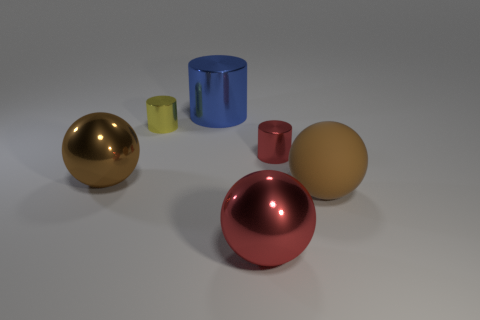Are there any other things that have the same material as the large cylinder?
Your answer should be very brief. Yes. What size is the red cylinder?
Provide a succinct answer. Small. What material is the large sphere left of the tiny cylinder that is on the left side of the large red shiny ball in front of the small red shiny cylinder made of?
Keep it short and to the point. Metal. What number of other objects are the same color as the matte sphere?
Provide a short and direct response. 1. What number of yellow things are large matte balls or metallic cylinders?
Provide a short and direct response. 1. There is a large brown thing that is in front of the big brown metal sphere; what material is it?
Make the answer very short. Rubber. Is the material of the brown sphere that is to the left of the small red metal cylinder the same as the blue cylinder?
Keep it short and to the point. Yes. What shape is the large brown rubber object?
Make the answer very short. Sphere. What number of red metal things are behind the small shiny cylinder that is behind the red thing right of the red sphere?
Provide a short and direct response. 0. How many other things are made of the same material as the red sphere?
Give a very brief answer. 4. 